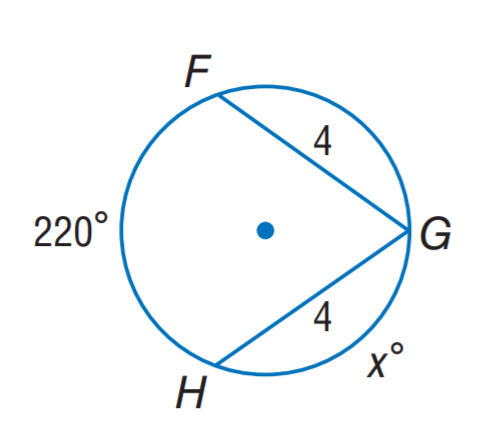Answer the mathemtical geometry problem and directly provide the correct option letter.
Question: Find x.
Choices: A: 20 B: 70 C: 110 D: 220 B 